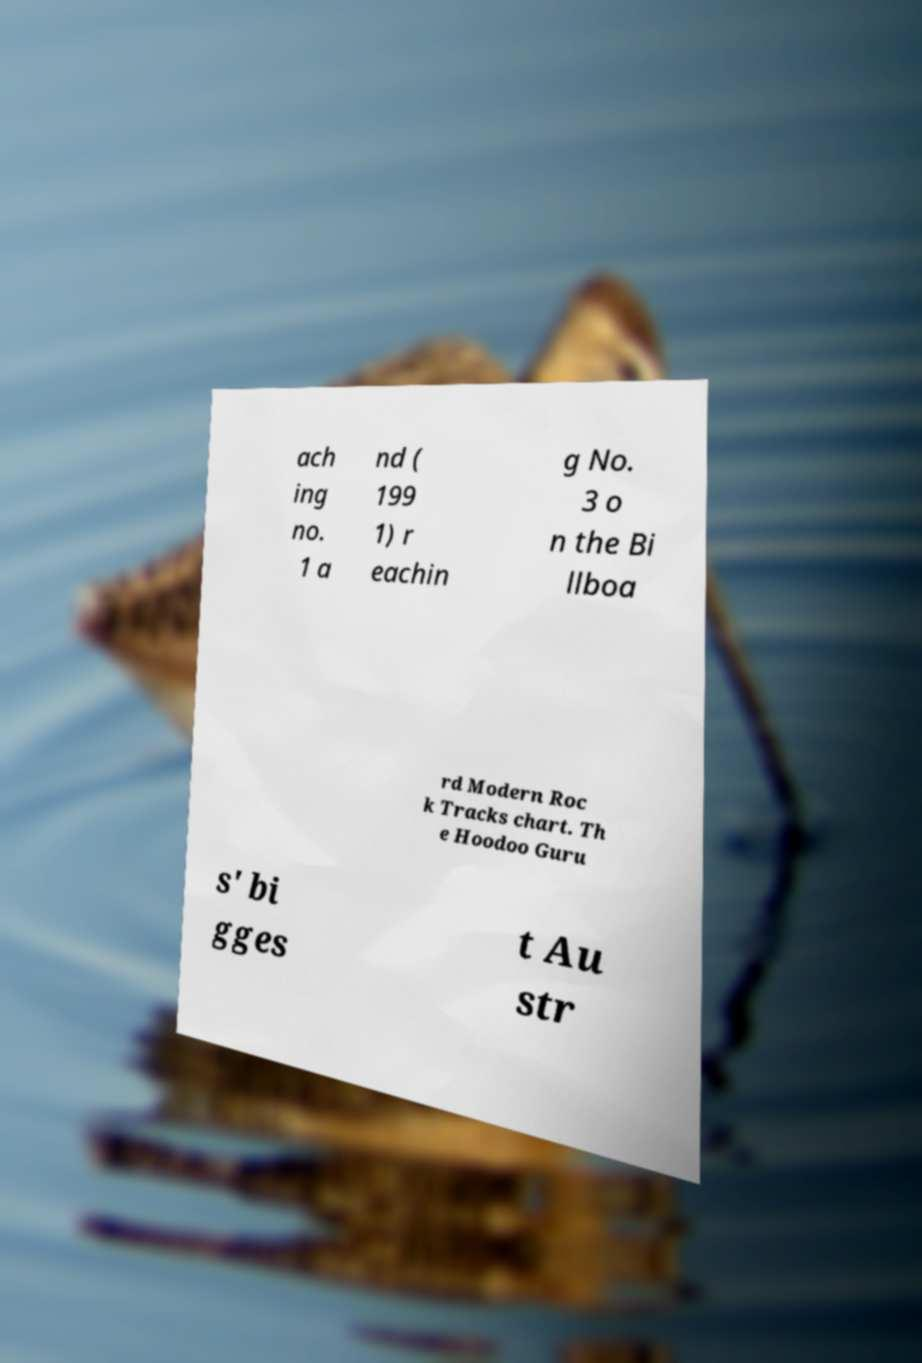Can you accurately transcribe the text from the provided image for me? ach ing no. 1 a nd ( 199 1) r eachin g No. 3 o n the Bi llboa rd Modern Roc k Tracks chart. Th e Hoodoo Guru s' bi gges t Au str 